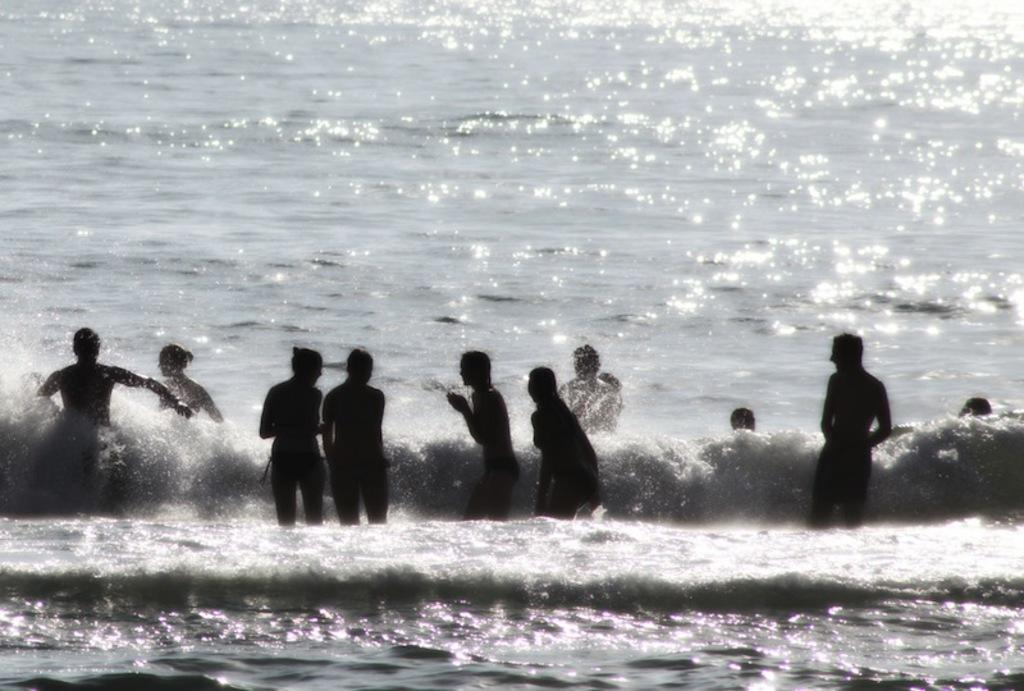What are the people in the image doing? The people in the image are standing in the water. What can be seen in the background of the image? There is an ocean in the background of the image. What type of jelly is being used to hold the people's brains in the image? There is no jelly or brains present in the image; it features people standing in the water with an ocean in the background. 